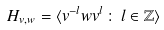<formula> <loc_0><loc_0><loc_500><loc_500>H _ { v , w } = \langle v ^ { - l } w v ^ { l } \, \colon \, l \in \mathbb { Z } \rangle</formula> 